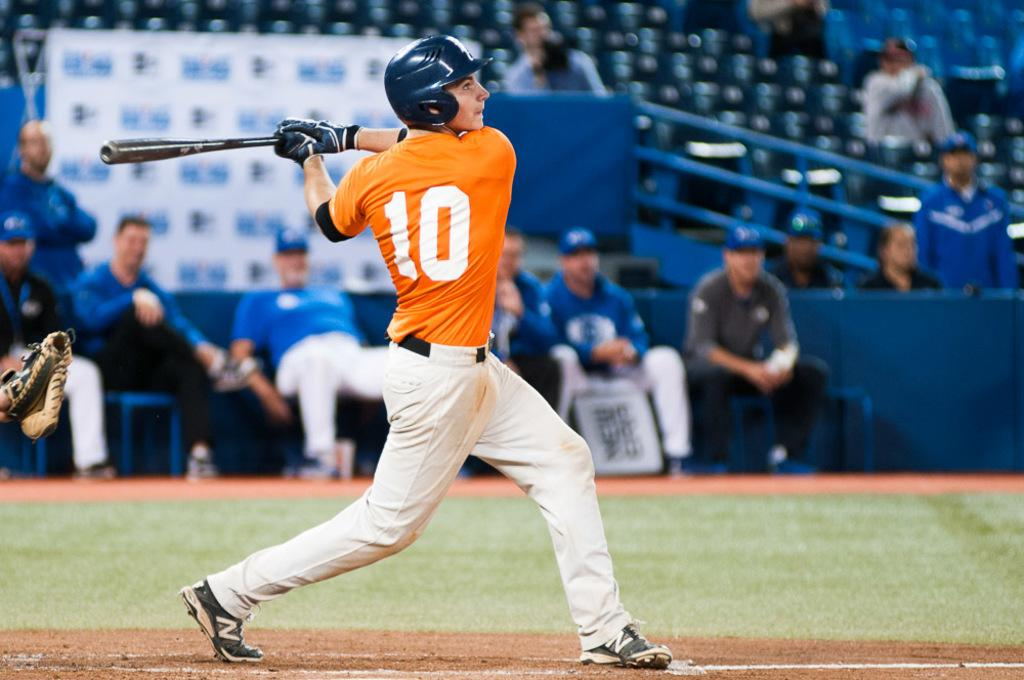<image>
Summarize the visual content of the image. A baseball player has the number 10 on the back of his shirt. 